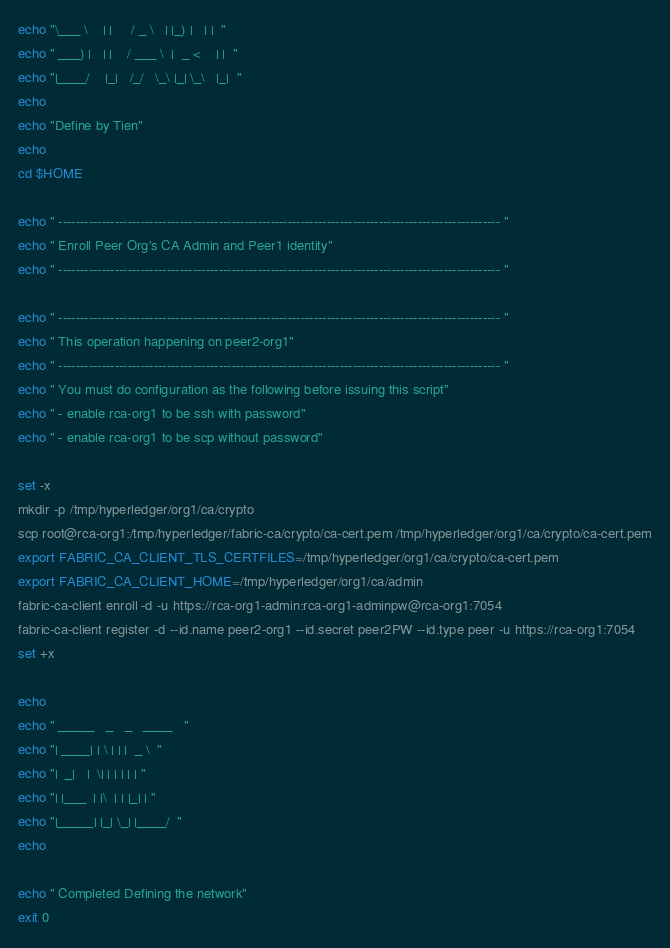Convert code to text. <code><loc_0><loc_0><loc_500><loc_500><_Bash_>echo "\___ \    | |     / _ \   | |_) |   | |  "
echo " ___) |   | |    / ___ \  |  _ <    | |  "
echo "|____/    |_|   /_/   \_\ |_| \_\   |_|  "
echo
echo "Define by Tien"
echo
cd $HOME

echo " ------------------------------------------------------------------------------------------------------ "
echo " Enroll Peer Org's CA Admin and Peer1 identity"
echo " ------------------------------------------------------------------------------------------------------ "

echo " ------------------------------------------------------------------------------------------------------ "
echo " This operation happening on peer2-org1"
echo " ------------------------------------------------------------------------------------------------------ "
echo " You must do configuration as the following before issuing this script"
echo " - enable rca-org1 to be ssh with password"
echo " - enable rca-org1 to be scp without password"

set -x
mkdir -p /tmp/hyperledger/org1/ca/crypto
scp root@rca-org1:/tmp/hyperledger/fabric-ca/crypto/ca-cert.pem /tmp/hyperledger/org1/ca/crypto/ca-cert.pem
export FABRIC_CA_CLIENT_TLS_CERTFILES=/tmp/hyperledger/org1/ca/crypto/ca-cert.pem
export FABRIC_CA_CLIENT_HOME=/tmp/hyperledger/org1/ca/admin
fabric-ca-client enroll -d -u https://rca-org1-admin:rca-org1-adminpw@rca-org1:7054
fabric-ca-client register -d --id.name peer2-org1 --id.secret peer2PW --id.type peer -u https://rca-org1:7054
set +x

echo
echo " _____   _   _   ____   "
echo "| ____| | \ | | |  _ \  "
echo "|  _|   |  \| | | | | | "
echo "| |___  | |\  | | |_| | "
echo "|_____| |_| \_| |____/  "
echo

echo " Completed Defining the network"
exit 0
</code> 